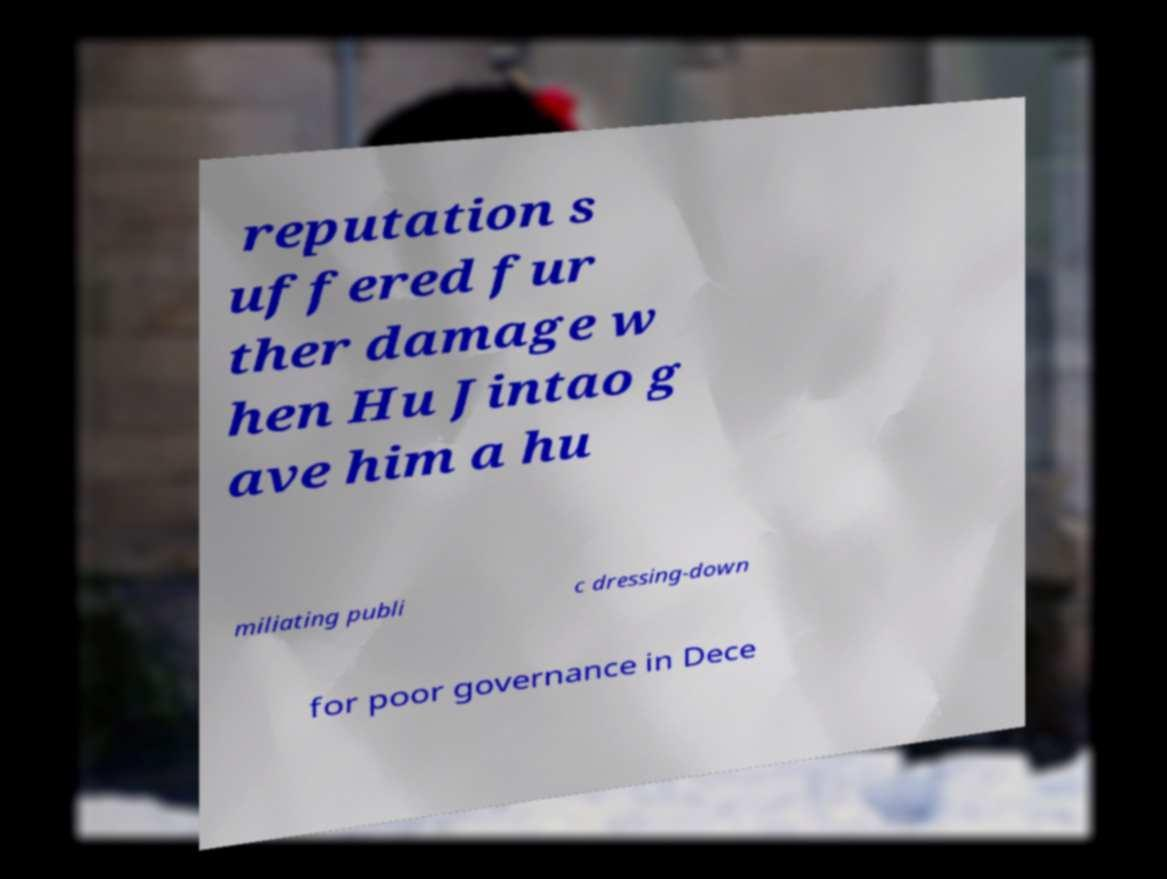What messages or text are displayed in this image? I need them in a readable, typed format. reputation s uffered fur ther damage w hen Hu Jintao g ave him a hu miliating publi c dressing-down for poor governance in Dece 